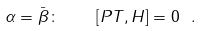Convert formula to latex. <formula><loc_0><loc_0><loc_500><loc_500>\alpha = \bar { \beta } \colon \quad [ P T , H ] = 0 \ .</formula> 